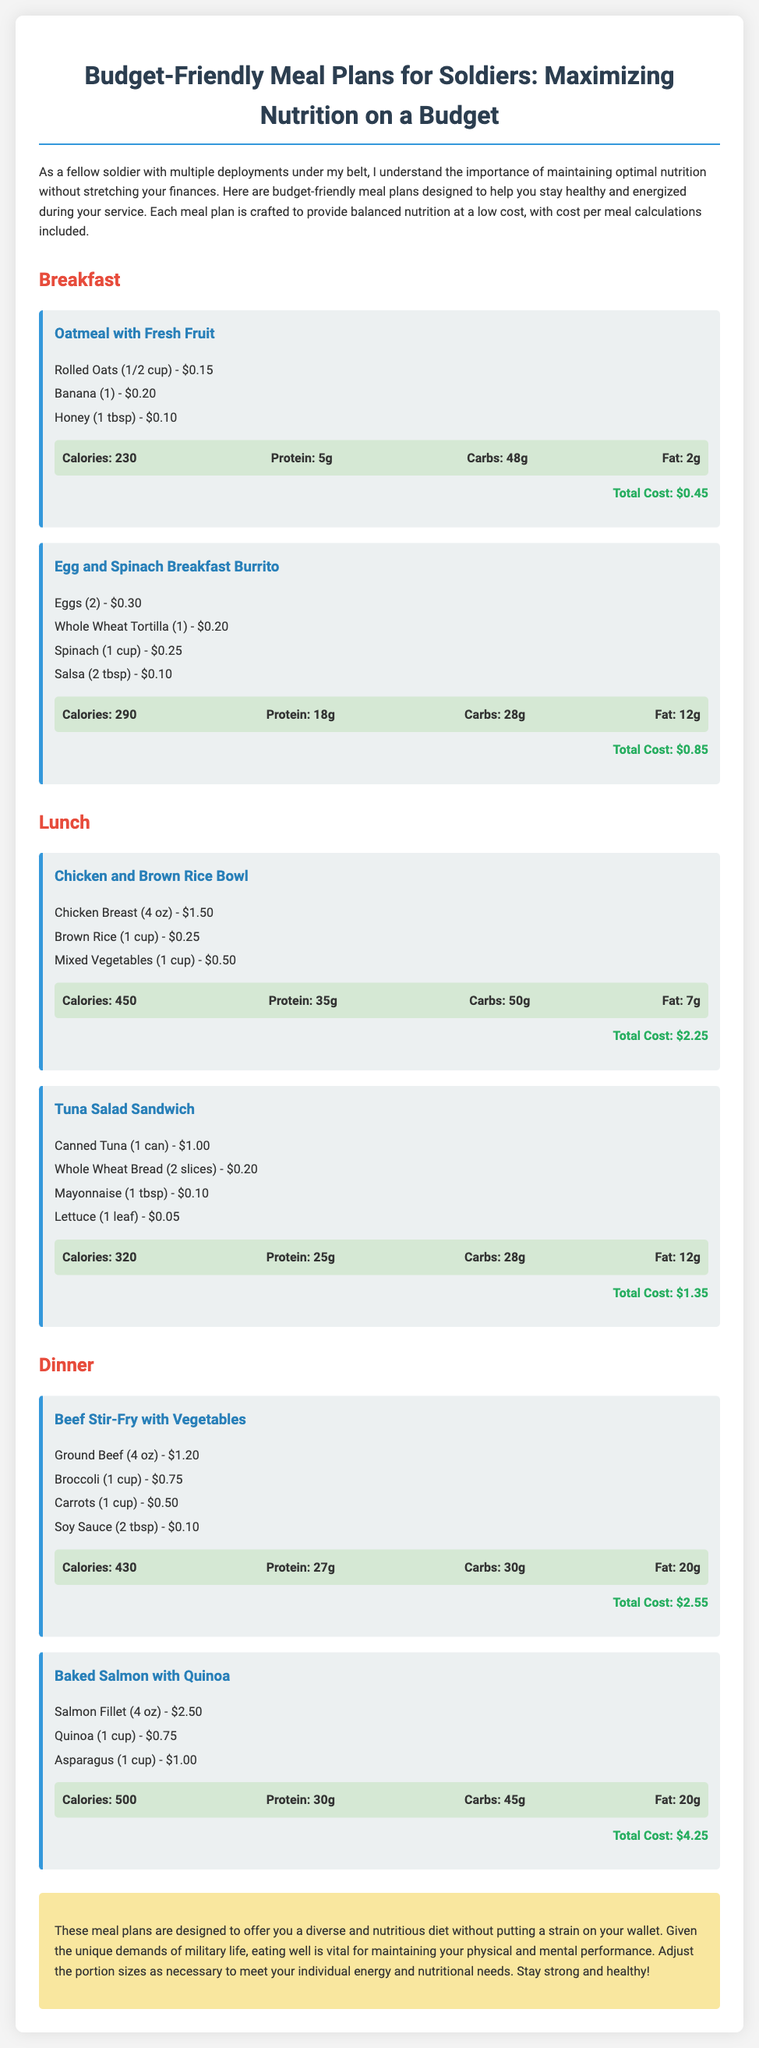what is the total cost of breakfast oatmeal with fresh fruit? The total cost of oatmeal with fresh fruit is calculated from the individual ingredient costs: $0.15 + $0.20 + $0.10 = $0.45.
Answer: $0.45 how many grams of protein are in the egg and spinach breakfast burrito? The protein content is specified in the meal description, which states that the burrito contains 18g of protein.
Answer: 18g what is the main source of protein in the chicken and brown rice bowl? The primary protein source in the chicken and brown rice bowl is the chicken breast as listed in the ingredients.
Answer: Chicken Breast how much does the baked salmon with quinoa cost? The cost for the meal, as mentioned in the document, is explicitly noted as $4.25.
Answer: $4.25 what is the calorie count of the beef stir-fry with vegetables? The calorie count for the beef stir-fry is provided in the nutrition section and totals 430 calories.
Answer: 430 which meal listed has the highest total cost? Among all meals detailed, the baked salmon with quinoa has the highest cost of $4.25.
Answer: Baked Salmon with Quinoa how many different lunch options are provided? The document lists two distinct lunch meals: Chicken and Brown Rice Bowl and Tuna Salad Sandwich.
Answer: 2 what is the total fat content in the tuna salad sandwich? The total fat content for the tuna salad sandwich is specified as 12g according to the nutrition information.
Answer: 12g what meal provides the most carbohydrates? The carbohydrate content for each meal indicates the Chicken and Brown Rice Bowl has the highest carbs at 50g.
Answer: Chicken and Brown Rice Bowl 